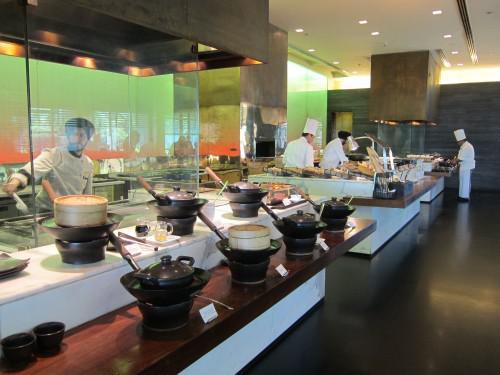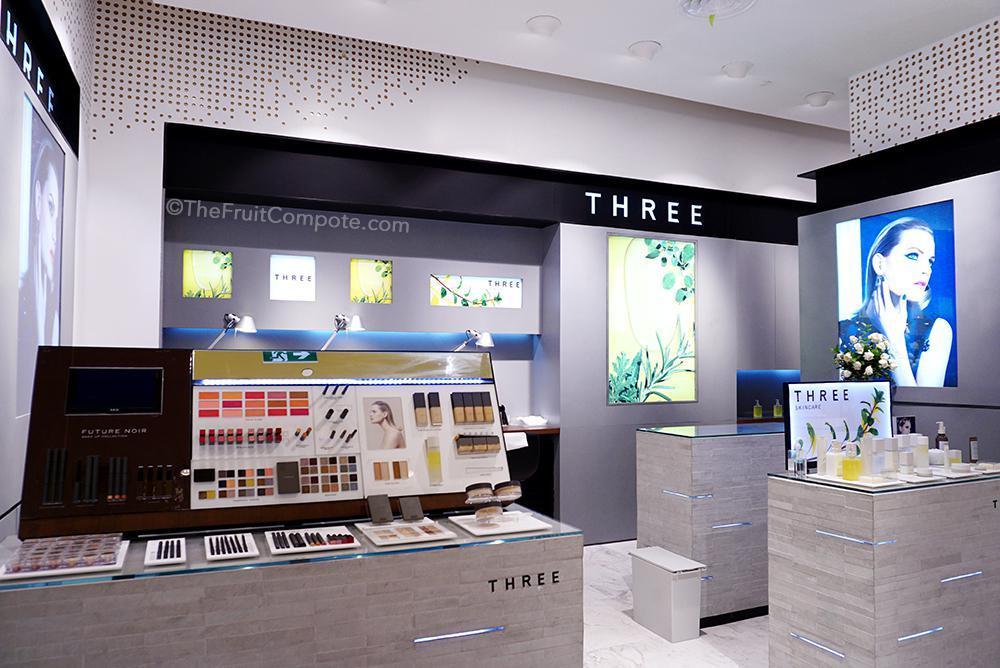The first image is the image on the left, the second image is the image on the right. Analyze the images presented: Is the assertion "One image shows a restaurant with a black band running around the top, with white lettering on it, and at least one rectangular upright stand under it." valid? Answer yes or no. Yes. The first image is the image on the left, the second image is the image on the right. Examine the images to the left and right. Is the description "There are people sitting in chairs in the left image." accurate? Answer yes or no. No. 